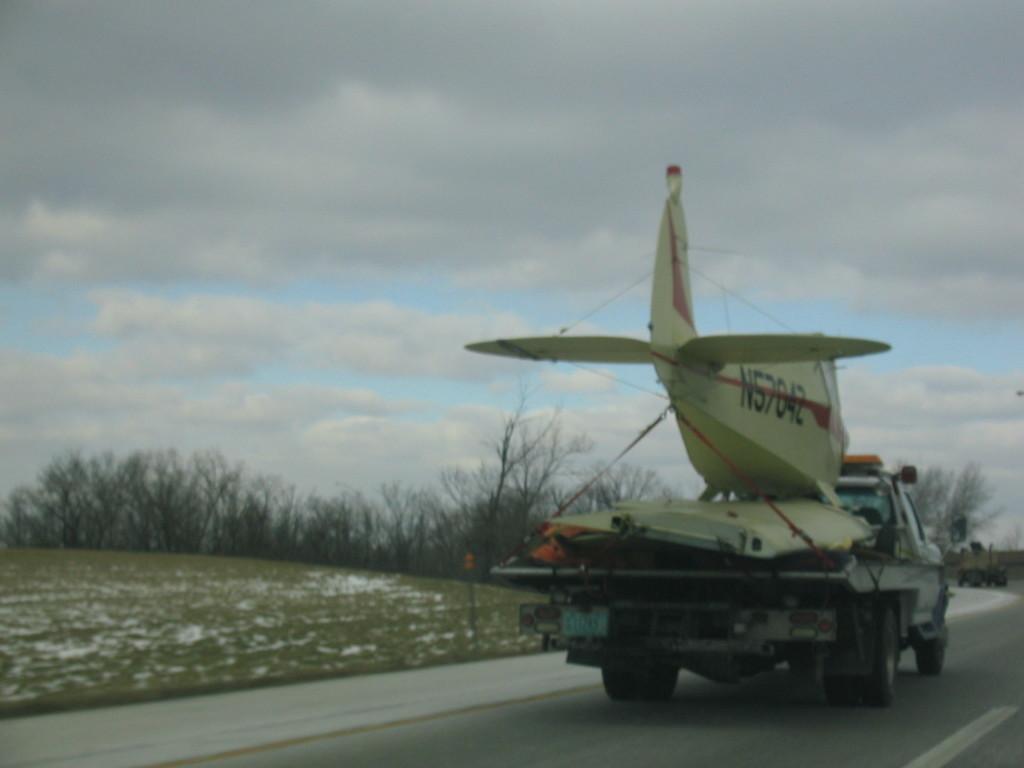Describe this image in one or two sentences. In this picture I can see the vehicles on the road. I can see green grass. I can see the aircraft. I can see trees. I can see clouds in the sky. 